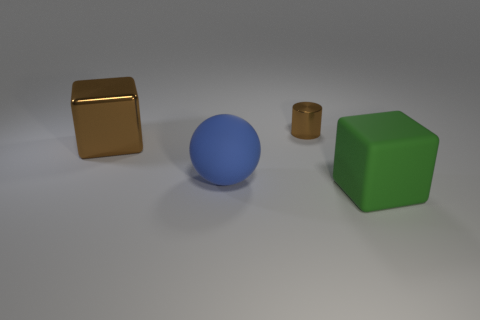Add 2 big rubber blocks. How many objects exist? 6 Subtract all cylinders. How many objects are left? 3 Add 1 blue matte cubes. How many blue matte cubes exist? 1 Subtract 0 yellow cylinders. How many objects are left? 4 Subtract all blue blocks. Subtract all yellow cylinders. How many blocks are left? 2 Subtract all tiny things. Subtract all large blue things. How many objects are left? 2 Add 3 blue rubber balls. How many blue rubber balls are left? 4 